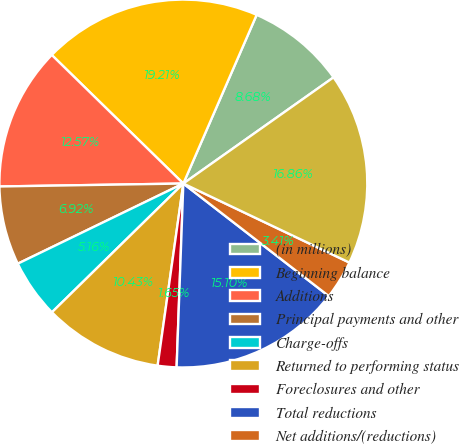<chart> <loc_0><loc_0><loc_500><loc_500><pie_chart><fcel>(in millions)<fcel>Beginning balance<fcel>Additions<fcel>Principal payments and other<fcel>Charge-offs<fcel>Returned to performing status<fcel>Foreclosures and other<fcel>Total reductions<fcel>Net additions/(reductions)<fcel>Ending balance<nl><fcel>8.68%<fcel>19.21%<fcel>12.57%<fcel>6.92%<fcel>5.16%<fcel>10.43%<fcel>1.65%<fcel>15.1%<fcel>3.41%<fcel>16.86%<nl></chart> 